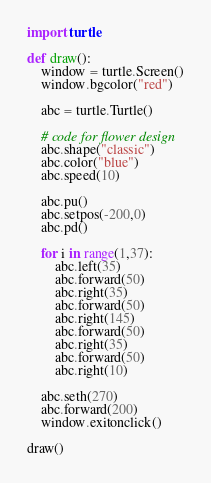<code> <loc_0><loc_0><loc_500><loc_500><_Python_>import turtle

def draw():
	window = turtle.Screen()
	window.bgcolor("red")
	
	abc = turtle.Turtle()
	
	# code for flower design
	abc.shape("classic")
	abc.color("blue")
	abc.speed(10)

	abc.pu()
	abc.setpos(-200,0)
	abc.pd()

	for i in range(1,37):  
		abc.left(35)
		abc.forward(50)
		abc.right(35)
		abc.forward(50)
		abc.right(145)
		abc.forward(50)
		abc.right(35)
		abc.forward(50)
		abc.right(10)
		
	abc.seth(270)
	abc.forward(200)
	window.exitonclick()

draw()
</code> 